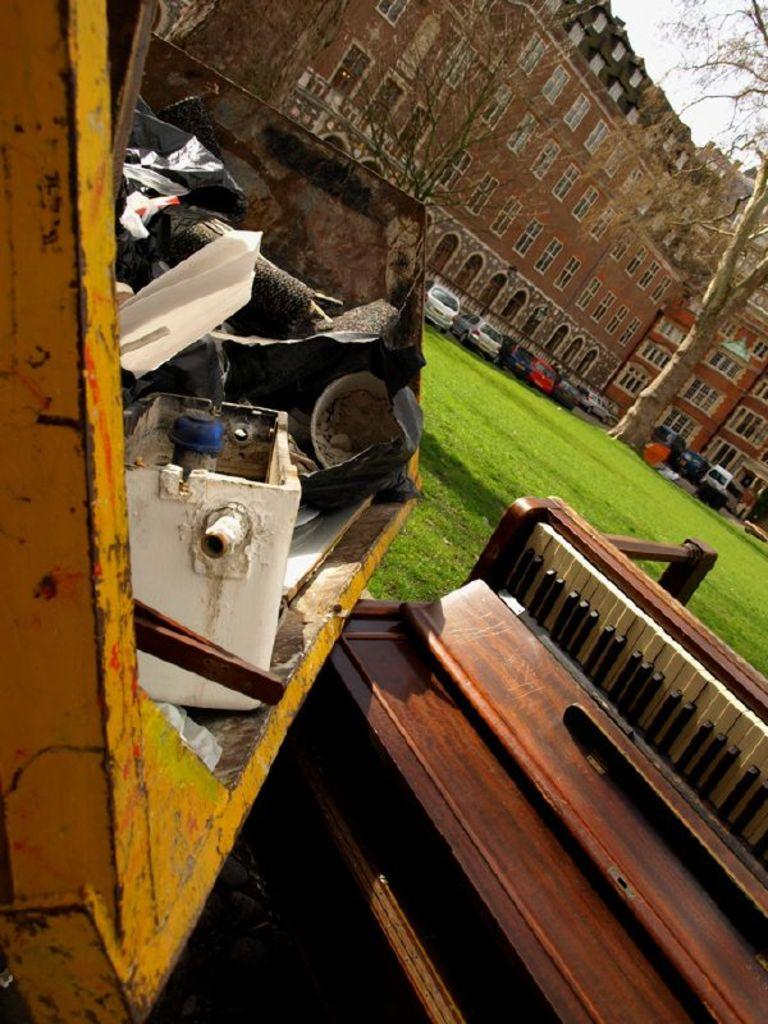What type of structure can be seen in the image? There is a building in the image. What part of the natural environment is visible in the image? The sky is visible in the image, as well as a tree and grass. What type of vehicles are present in the image? There are cars in the image. What object is used for waste disposal in the image? There is a dustbin in the image. What musical instrument can be seen in the image? There is a musical keyboard in the image. Can you tell me how many rabbits are hopping around the musical keyboard in the image? There are no rabbits present in the image; it features a building, sky, tree, grass, cars, a dustbin, and a musical keyboard. 